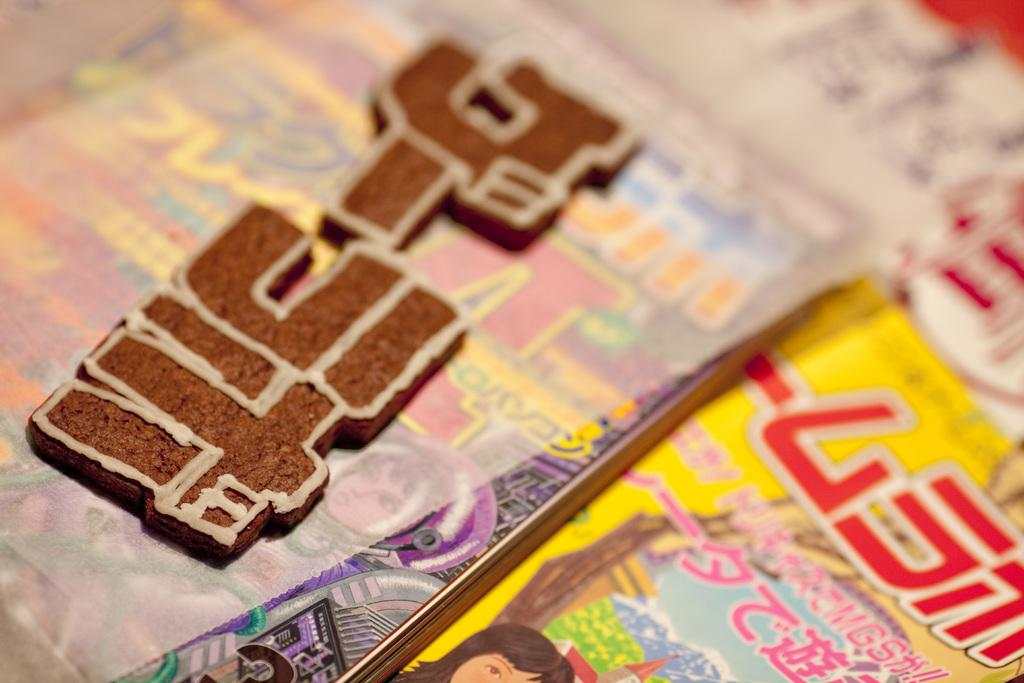What type of objects can be seen in the image? There are books and a paper in the image. Can you describe the paper in the image? The paper is a single sheet in the image. How many books are visible in the image? The number of books visible in the image is not specified, but there are at least two objects that appear to be books. What type of drink is being consumed by the person in the image? There is no person or drink present in the image; it only features books and a paper. 